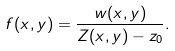<formula> <loc_0><loc_0><loc_500><loc_500>f ( x , y ) = \frac { w ( x , y ) } { Z ( x , y ) - z _ { 0 } } .</formula> 